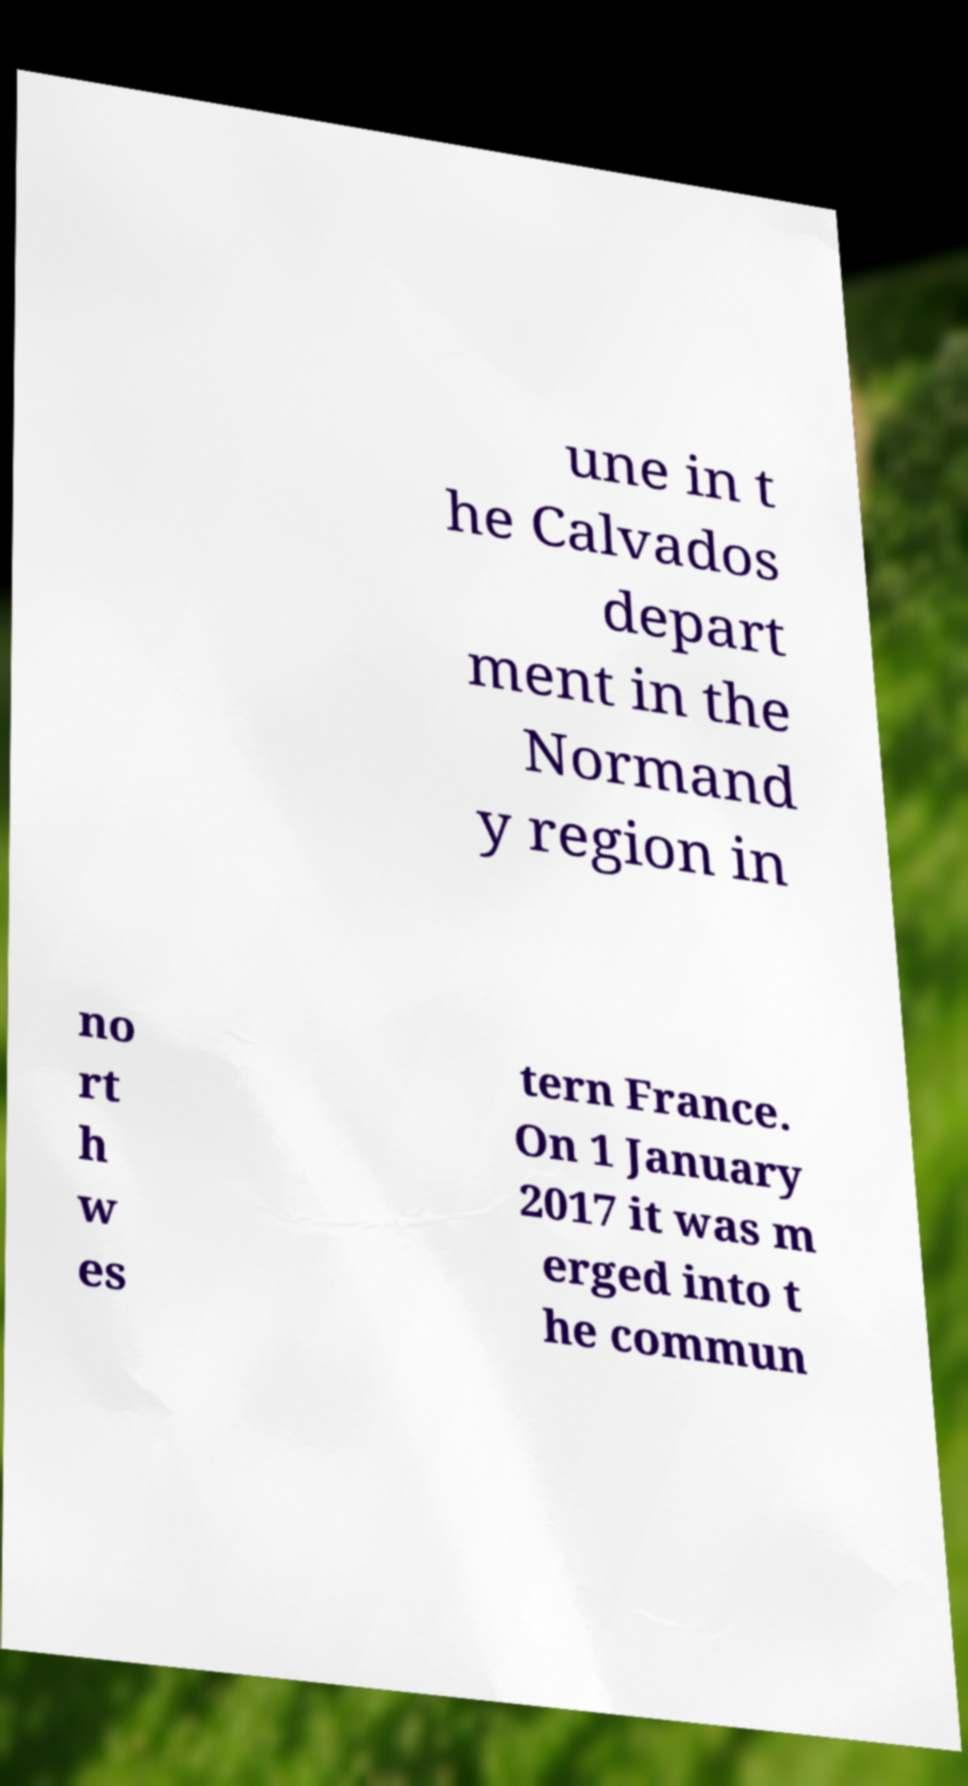Could you extract and type out the text from this image? une in t he Calvados depart ment in the Normand y region in no rt h w es tern France. On 1 January 2017 it was m erged into t he commun 